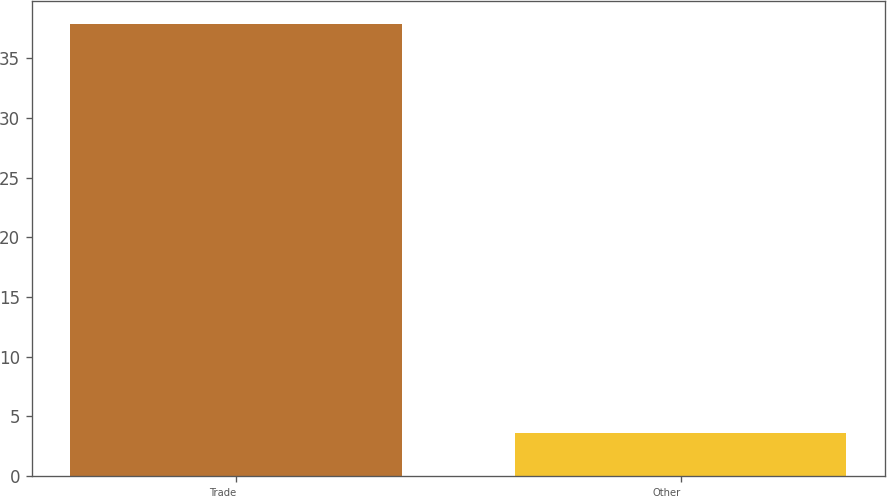<chart> <loc_0><loc_0><loc_500><loc_500><bar_chart><fcel>Trade<fcel>Other<nl><fcel>37.9<fcel>3.6<nl></chart> 